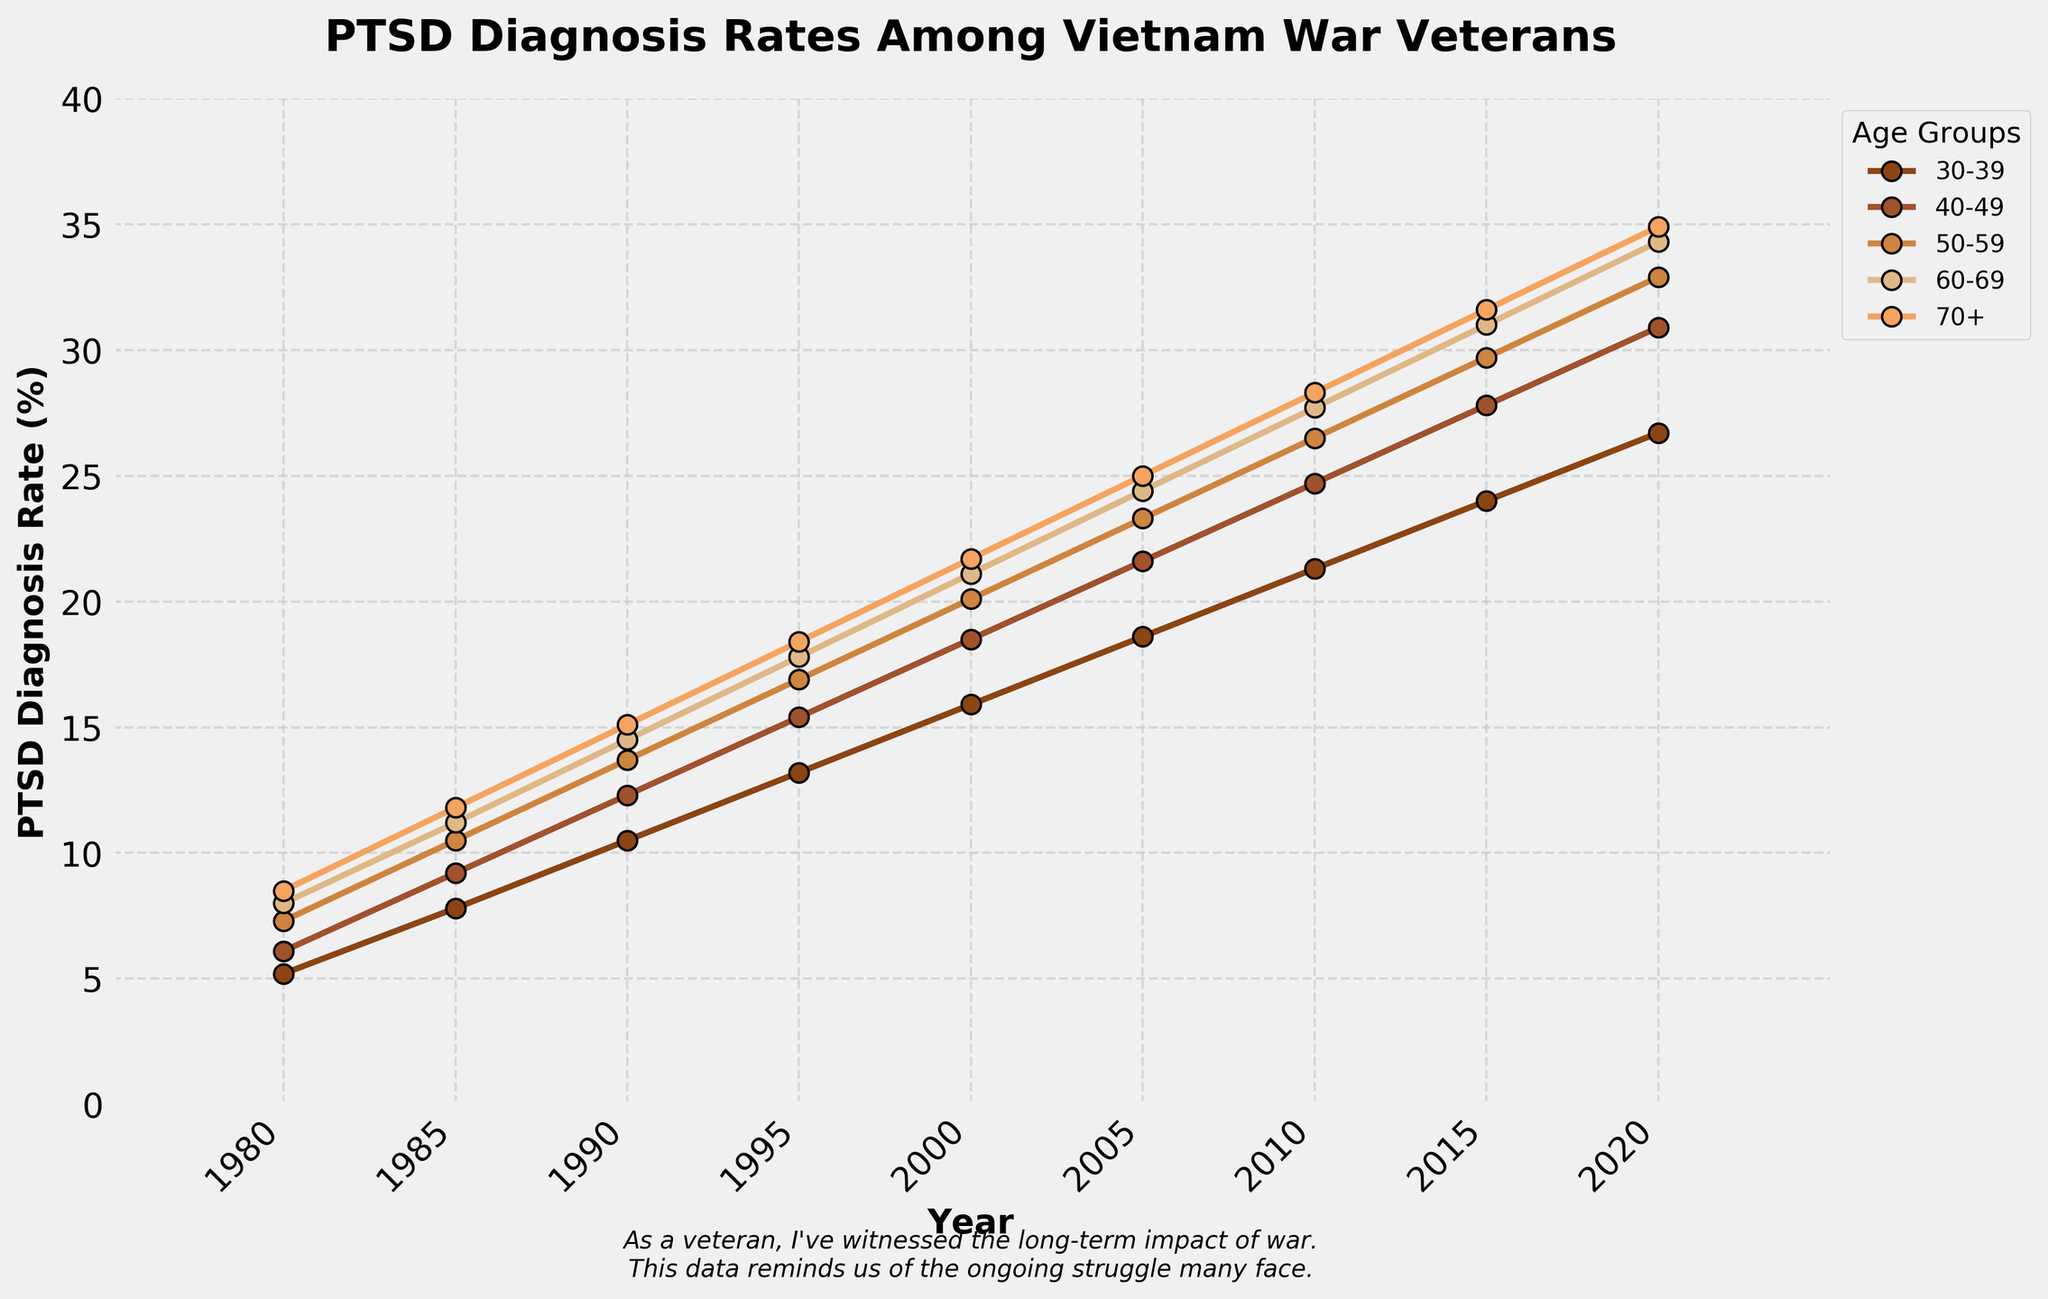What year did the 30-39 age group see the highest rate of PTSD diagnosis? To answer this question, look at the points on the plot for the 30-39 age group to identify the maximum value. The highest PTSD diagnosis rate for the 30-39 age group is shown at the year 2020, where the rate is 26.7%.
Answer: 2020 What is the difference in PTSD diagnosis rates between the 70+ age group and the 30-39 age group in 2000? Identify the PTSD diagnosis rates for both age groups in the year 2000: the 70+ group has a rate of 21.7%, and the 30-39 group has a rate of 15.9%. Subtract the 30-39 rate from the 70+ rate: 21.7% - 15.9% = 5.8%.
Answer: 5.8% Which age group had the steepest increase in PTSD diagnosis rates between 1980 and 2020? Calculate the differences for each age group by subtracting the 1980 rate from the 2020 rate. The differences are: 30-39: 26.7% - 5.2% = 21.5%, 40-49: 30.9% - 6.1% = 24.8%, 50-59: 32.9% - 7.3% = 25.6%, 60-69: 34.3% - 8.0% = 26.3%, 70+: 34.9% - 8.5% = 26.4%. The 70+ age group had the steepest increase.
Answer: 70+ What year does the PTSD diagnosis rate for the 60-69 age group first exceed 20%? Examine the plot line for the 60-69 age group. The rate exceeds 20% between 1995 (17.8%) and 2000 (21.1%), so the first year it exceeds 20% is 2000.
Answer: 2000 Comparing the 50-59 and 60-69 age groups, which had a higher PTSD diagnosis rate in 2015? Identify the PTSD diagnosis rates for both age groups in 2015. For the 50-59 age group, the rate is 29.7%, and for the 60-69 age group, the rate is 31.0%. The 60-69 age group had a higher rate.
Answer: 60-69 What are the average PTSD diagnosis rates for the 60-69 age group across the entire time period? Add up the rates for the 60-69 age group and divide by the number of data points (9): (8.0 + 11.2 + 14.5 + 17.8 + 21.1 + 24.4 + 27.7 + 31.0 + 34.3) / 9 = 20.0%
Answer: 20.0% Which age group had the largest jump in diagnosis rates between any two consecutive data points within the dataset? Examine changes between consecutive time points for each age group: the largest jump is between 2000 and 2005 for the 70+ age group, where the difference is 25.0% - 21.7% = 3.3%.
Answer: 70+ Which age group maintained the most consistent increase in PTSD diagnosis rates over the years, with the least fluctuation in jumps between consecutive years? Look for the age group with the smallest variation in rate increases between consecutive data points. The 30-39 and 40-49 age groups show smaller and more consistent increases compared to other groups. But 30-39 shows slightly more steady increments.
Answer: 30-39 